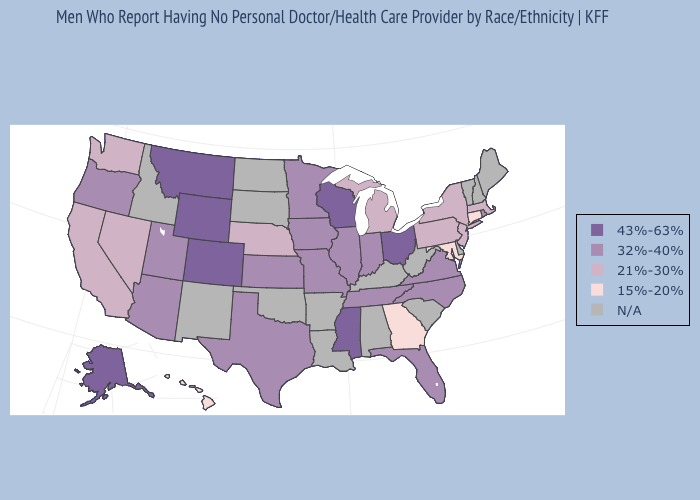Which states hav the highest value in the West?
Quick response, please. Alaska, Colorado, Montana, Wyoming. Name the states that have a value in the range 43%-63%?
Quick response, please. Alaska, Colorado, Mississippi, Montana, Ohio, Wisconsin, Wyoming. Does Hawaii have the lowest value in the West?
Concise answer only. Yes. Which states have the highest value in the USA?
Concise answer only. Alaska, Colorado, Mississippi, Montana, Ohio, Wisconsin, Wyoming. What is the value of Iowa?
Write a very short answer. 32%-40%. What is the value of Iowa?
Quick response, please. 32%-40%. What is the value of Maryland?
Be succinct. 15%-20%. Which states have the highest value in the USA?
Give a very brief answer. Alaska, Colorado, Mississippi, Montana, Ohio, Wisconsin, Wyoming. What is the lowest value in states that border Montana?
Concise answer only. 43%-63%. Does Wisconsin have the lowest value in the MidWest?
Write a very short answer. No. What is the value of North Dakota?
Be succinct. N/A. Name the states that have a value in the range 32%-40%?
Write a very short answer. Arizona, Florida, Illinois, Indiana, Iowa, Kansas, Minnesota, Missouri, North Carolina, Oregon, Rhode Island, Tennessee, Texas, Utah, Virginia. What is the value of West Virginia?
Give a very brief answer. N/A. 